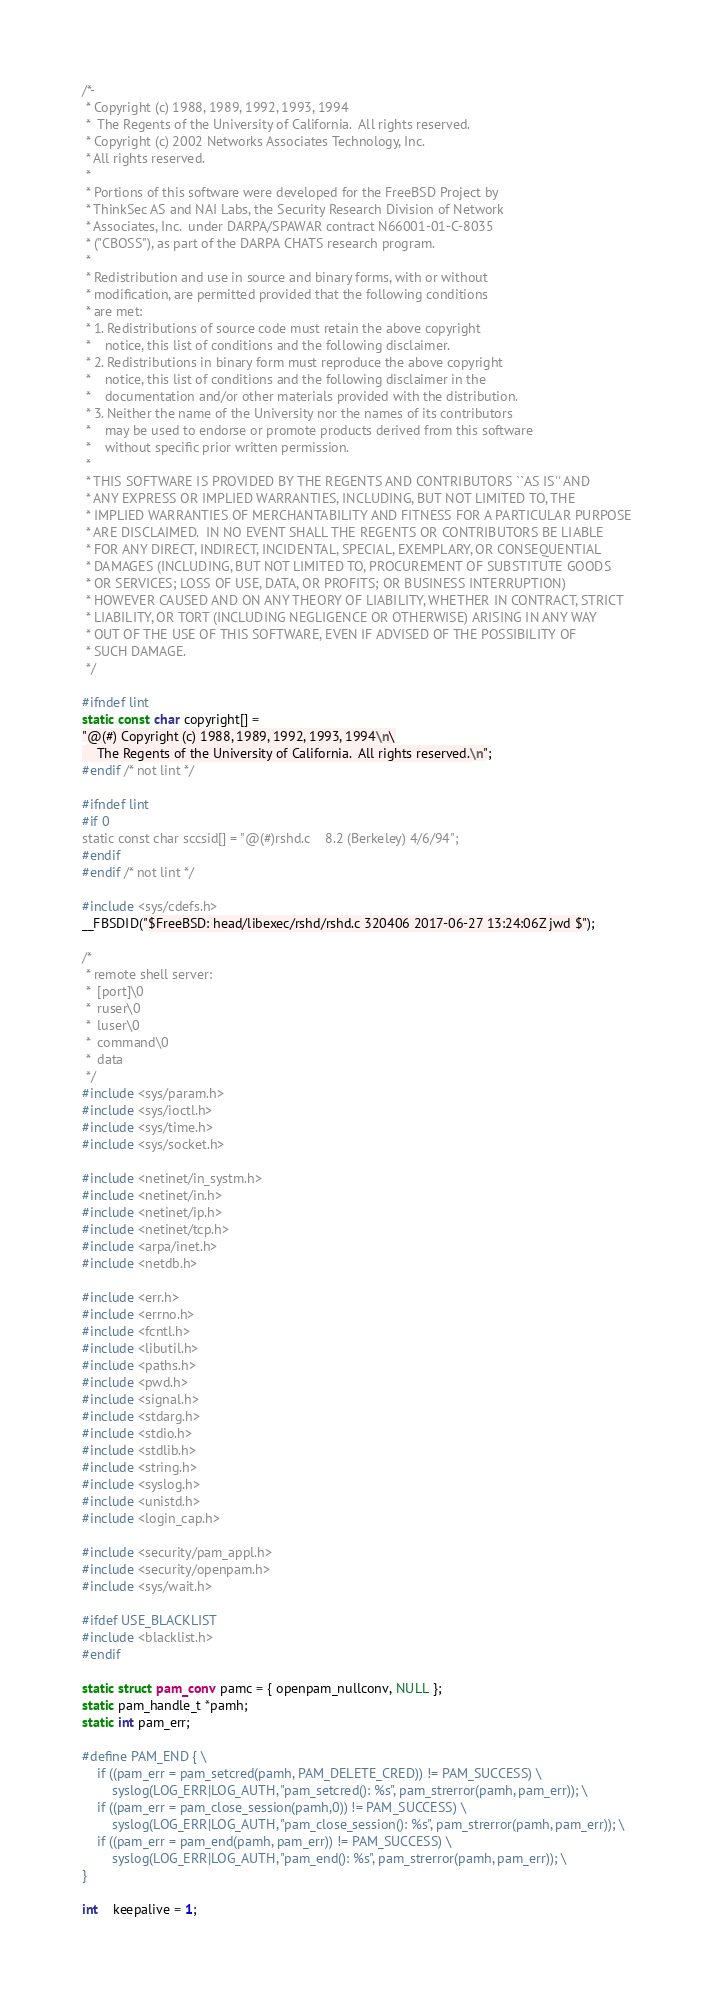Convert code to text. <code><loc_0><loc_0><loc_500><loc_500><_C_>/*-
 * Copyright (c) 1988, 1989, 1992, 1993, 1994
 *	The Regents of the University of California.  All rights reserved.
 * Copyright (c) 2002 Networks Associates Technology, Inc.
 * All rights reserved.
 *
 * Portions of this software were developed for the FreeBSD Project by
 * ThinkSec AS and NAI Labs, the Security Research Division of Network
 * Associates, Inc.  under DARPA/SPAWAR contract N66001-01-C-8035
 * ("CBOSS"), as part of the DARPA CHATS research program.
 *
 * Redistribution and use in source and binary forms, with or without
 * modification, are permitted provided that the following conditions
 * are met:
 * 1. Redistributions of source code must retain the above copyright
 *    notice, this list of conditions and the following disclaimer.
 * 2. Redistributions in binary form must reproduce the above copyright
 *    notice, this list of conditions and the following disclaimer in the
 *    documentation and/or other materials provided with the distribution.
 * 3. Neither the name of the University nor the names of its contributors
 *    may be used to endorse or promote products derived from this software
 *    without specific prior written permission.
 *
 * THIS SOFTWARE IS PROVIDED BY THE REGENTS AND CONTRIBUTORS ``AS IS'' AND
 * ANY EXPRESS OR IMPLIED WARRANTIES, INCLUDING, BUT NOT LIMITED TO, THE
 * IMPLIED WARRANTIES OF MERCHANTABILITY AND FITNESS FOR A PARTICULAR PURPOSE
 * ARE DISCLAIMED.  IN NO EVENT SHALL THE REGENTS OR CONTRIBUTORS BE LIABLE
 * FOR ANY DIRECT, INDIRECT, INCIDENTAL, SPECIAL, EXEMPLARY, OR CONSEQUENTIAL
 * DAMAGES (INCLUDING, BUT NOT LIMITED TO, PROCUREMENT OF SUBSTITUTE GOODS
 * OR SERVICES; LOSS OF USE, DATA, OR PROFITS; OR BUSINESS INTERRUPTION)
 * HOWEVER CAUSED AND ON ANY THEORY OF LIABILITY, WHETHER IN CONTRACT, STRICT
 * LIABILITY, OR TORT (INCLUDING NEGLIGENCE OR OTHERWISE) ARISING IN ANY WAY
 * OUT OF THE USE OF THIS SOFTWARE, EVEN IF ADVISED OF THE POSSIBILITY OF
 * SUCH DAMAGE.
 */

#ifndef lint
static const char copyright[] =
"@(#) Copyright (c) 1988, 1989, 1992, 1993, 1994\n\
	The Regents of the University of California.  All rights reserved.\n";
#endif /* not lint */

#ifndef lint
#if 0
static const char sccsid[] = "@(#)rshd.c	8.2 (Berkeley) 4/6/94";
#endif
#endif /* not lint */

#include <sys/cdefs.h>
__FBSDID("$FreeBSD: head/libexec/rshd/rshd.c 320406 2017-06-27 13:24:06Z jwd $");

/*
 * remote shell server:
 *	[port]\0
 *	ruser\0
 *	luser\0
 *	command\0
 *	data
 */
#include <sys/param.h>
#include <sys/ioctl.h>
#include <sys/time.h>
#include <sys/socket.h>

#include <netinet/in_systm.h>
#include <netinet/in.h>
#include <netinet/ip.h>
#include <netinet/tcp.h>
#include <arpa/inet.h>
#include <netdb.h>

#include <err.h>
#include <errno.h>
#include <fcntl.h>
#include <libutil.h>
#include <paths.h>
#include <pwd.h>
#include <signal.h>
#include <stdarg.h>
#include <stdio.h>
#include <stdlib.h>
#include <string.h>
#include <syslog.h>
#include <unistd.h>
#include <login_cap.h>

#include <security/pam_appl.h>
#include <security/openpam.h>
#include <sys/wait.h>

#ifdef USE_BLACKLIST
#include <blacklist.h>
#endif

static struct pam_conv pamc = { openpam_nullconv, NULL };
static pam_handle_t *pamh;
static int pam_err;

#define PAM_END { \
	if ((pam_err = pam_setcred(pamh, PAM_DELETE_CRED)) != PAM_SUCCESS) \
		syslog(LOG_ERR|LOG_AUTH, "pam_setcred(): %s", pam_strerror(pamh, pam_err)); \
	if ((pam_err = pam_close_session(pamh,0)) != PAM_SUCCESS) \
		syslog(LOG_ERR|LOG_AUTH, "pam_close_session(): %s", pam_strerror(pamh, pam_err)); \
	if ((pam_err = pam_end(pamh, pam_err)) != PAM_SUCCESS) \
		syslog(LOG_ERR|LOG_AUTH, "pam_end(): %s", pam_strerror(pamh, pam_err)); \
}

int	keepalive = 1;</code> 